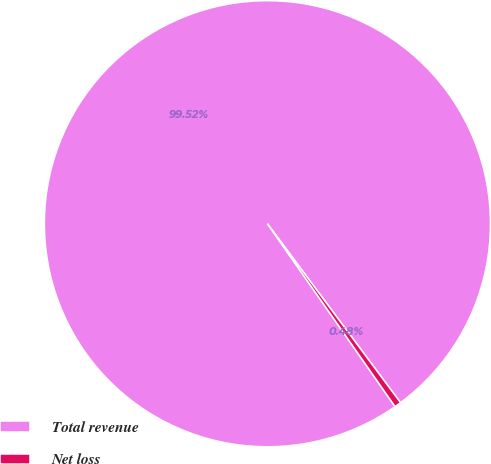Convert chart to OTSL. <chart><loc_0><loc_0><loc_500><loc_500><pie_chart><fcel>Total revenue<fcel>Net loss<nl><fcel>99.52%<fcel>0.48%<nl></chart> 